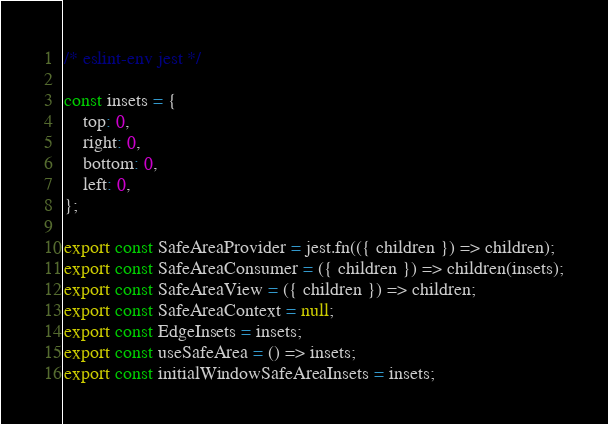Convert code to text. <code><loc_0><loc_0><loc_500><loc_500><_JavaScript_>/* eslint-env jest */

const insets = {
    top: 0,
    right: 0,
    bottom: 0,
    left: 0,
};

export const SafeAreaProvider = jest.fn(({ children }) => children);
export const SafeAreaConsumer = ({ children }) => children(insets);
export const SafeAreaView = ({ children }) => children;
export const SafeAreaContext = null;
export const EdgeInsets = insets;
export const useSafeArea = () => insets;
export const initialWindowSafeAreaInsets = insets;

</code> 